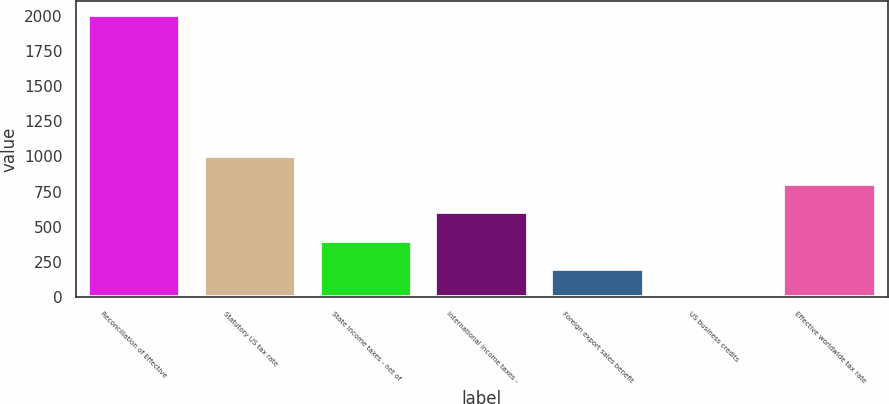Convert chart to OTSL. <chart><loc_0><loc_0><loc_500><loc_500><bar_chart><fcel>Reconciliation of Effective<fcel>Statutory US tax rate<fcel>State income taxes - net of<fcel>International income taxes -<fcel>Foreign export sales benefit<fcel>US business credits<fcel>Effective worldwide tax rate<nl><fcel>2004<fcel>1002.2<fcel>401.12<fcel>601.48<fcel>200.76<fcel>0.4<fcel>801.84<nl></chart> 